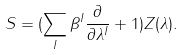Convert formula to latex. <formula><loc_0><loc_0><loc_500><loc_500>S = ( \sum _ { I } \beta ^ { I } \frac { \partial } { \partial \lambda ^ { I } } + 1 ) Z ( \lambda ) .</formula> 